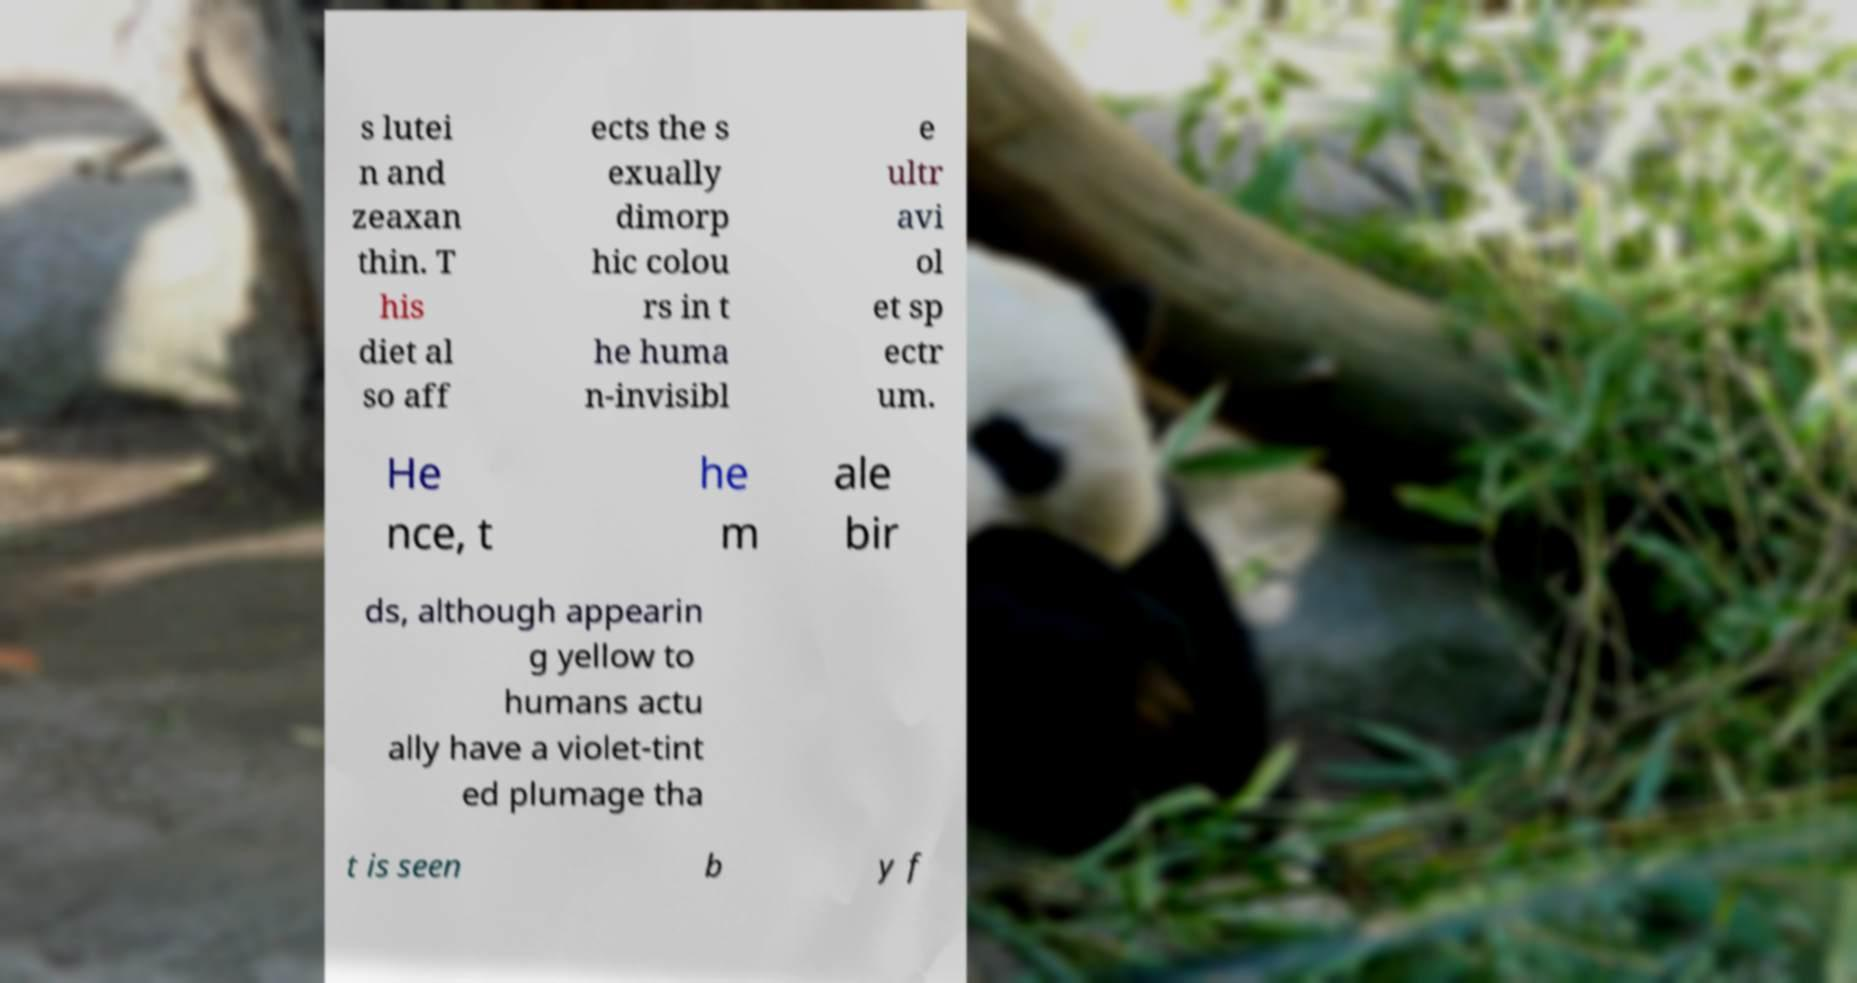Can you accurately transcribe the text from the provided image for me? s lutei n and zeaxan thin. T his diet al so aff ects the s exually dimorp hic colou rs in t he huma n-invisibl e ultr avi ol et sp ectr um. He nce, t he m ale bir ds, although appearin g yellow to humans actu ally have a violet-tint ed plumage tha t is seen b y f 